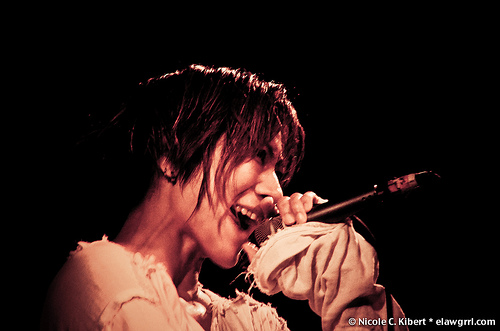<image>
Is there a microphone next to the person? Yes. The microphone is positioned adjacent to the person, located nearby in the same general area. 